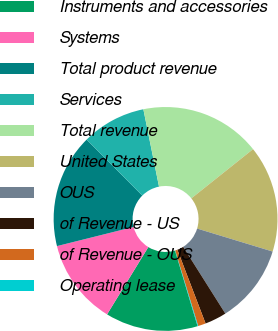Convert chart. <chart><loc_0><loc_0><loc_500><loc_500><pie_chart><fcel>Instruments and accessories<fcel>Systems<fcel>Total product revenue<fcel>Services<fcel>Total revenue<fcel>United States<fcel>OUS<fcel>of Revenue - US<fcel>of Revenue - OUS<fcel>Operating lease<nl><fcel>13.37%<fcel>12.35%<fcel>16.44%<fcel>9.28%<fcel>17.46%<fcel>15.42%<fcel>11.33%<fcel>3.15%<fcel>1.11%<fcel>0.09%<nl></chart> 